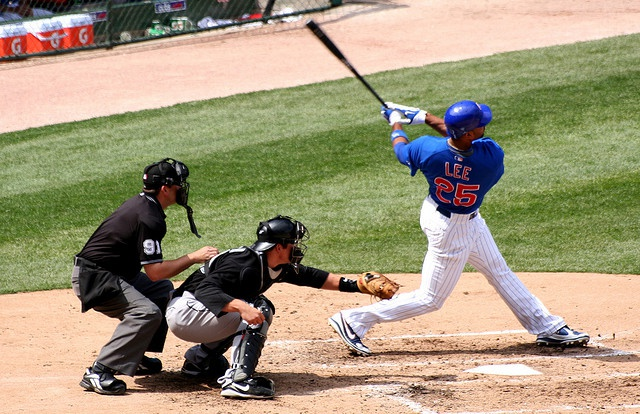Describe the objects in this image and their specific colors. I can see people in black, lavender, navy, and darkgray tones, people in black, gray, darkgray, and maroon tones, people in black, gray, white, and maroon tones, baseball glove in black, tan, maroon, and brown tones, and baseball bat in black, gray, darkgreen, and maroon tones in this image. 